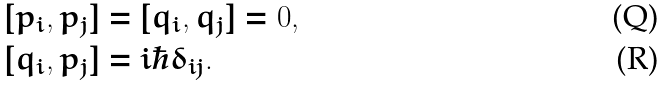<formula> <loc_0><loc_0><loc_500><loc_500>[ p _ { i } , p _ { j } ] & = [ q _ { i } , q _ { j } ] = 0 , \\ [ q _ { i } , p _ { j } ] & = i \hbar { \delta } _ { i j } .</formula> 